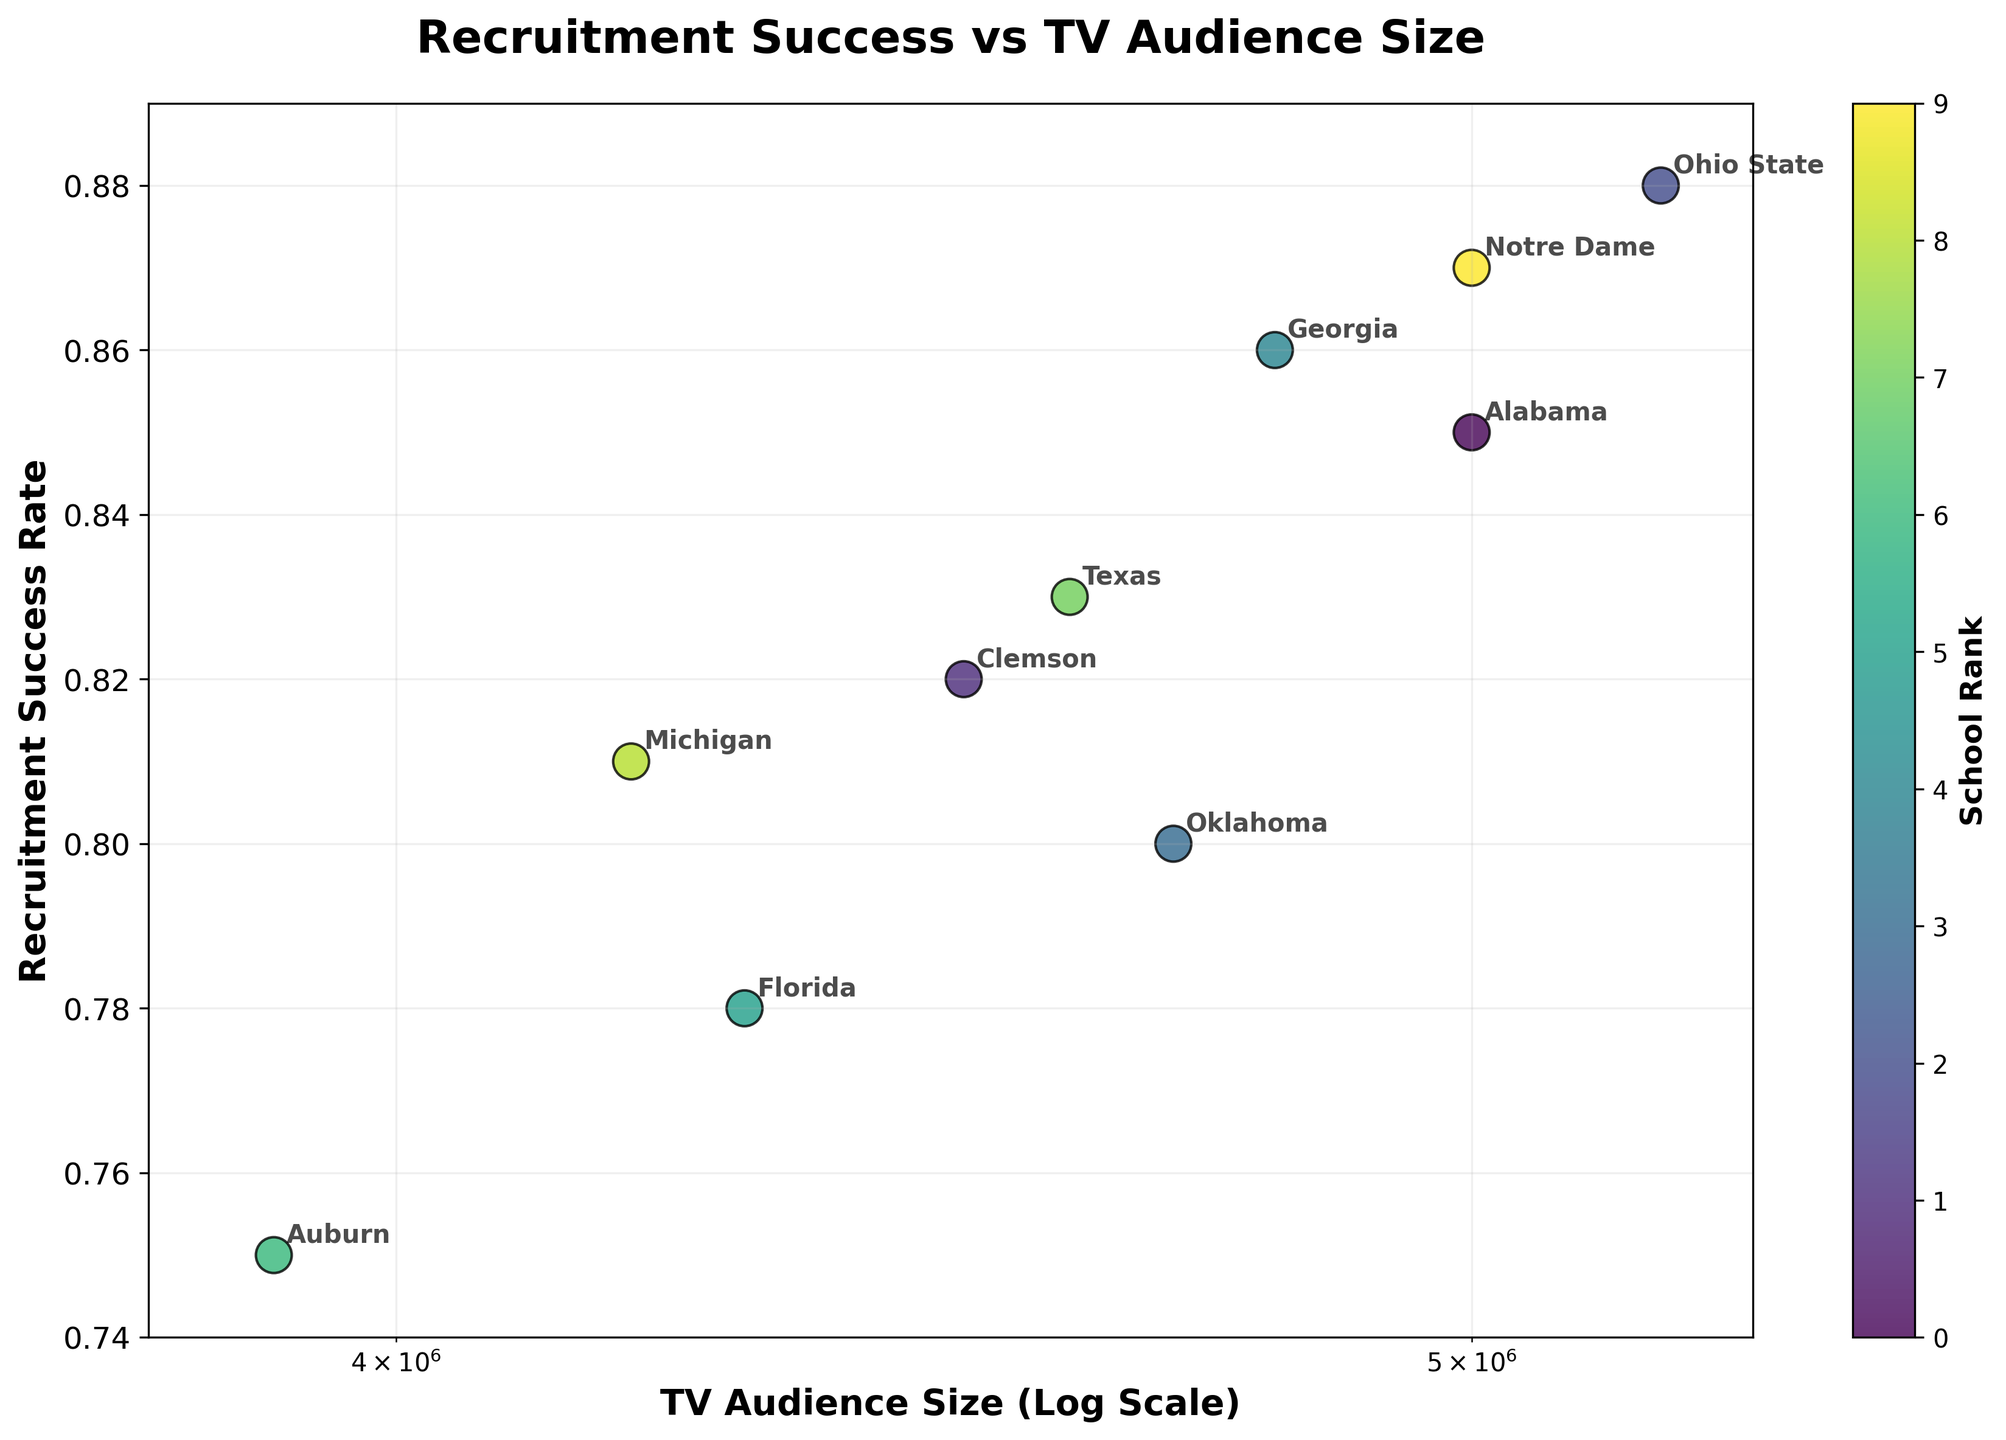What's the title of the figure? The title of the figure is located at the top and is usually displayed in a bold and larger font to summarize what the plot represents.
Answer: Recruitment Success vs TV Audience Size Which school has the highest recruitment success rate? By observing the y-axis (Recruitment Success Rate) and finding the highest point on the plot, and then looking at the label of the corresponding data point, you can identify which school has the highest recruitment success rate.
Answer: Ohio State What's the TV audience size for Michigan? Locate the data point labeled "Michigan" and find its position on the x-axis (TV Audience Size). This axis uses a log scale, so the values are logarithmically spaced.
Answer: 4200000 Between Auburn and Texas, which school has a higher TV audience size? Find the data points labeled "Auburn" and "Texas," then compare their positions on the x-axis. The one farther to the right has a higher TV audience size.
Answer: Texas How many schools have a recruitment success rate of 0.85 or higher? Count the number of data points with y-values (Recruitment Success Rate) equal to or greater than 0.85. Each point should have a label identifying the school.
Answer: 4 Which school has both a high recruitment success rate and a high TV audience size? Look for the data point that is high on the y-axis (Recruitment Success Rate) and far to the right on the x-axis (TV Audience Size). Confirm by checking the label.
Answer: Ohio State What’s the difference in recruitment success rate between the school with the highest rate and the school with the lowest rate? Identify the highest and lowest points on the y-axis and subtract the lowest rate from the highest rate. The highest rate is from Ohio State (0.88) and the lowest from Auburn (0.75).
Answer: 0.13 Which school appears closest to the average recruitment success rate of the displayed schools? Calculate the average recruitment success rate and identify the school closest to this value by comparing the y-values.
Answer: Texas Are there more schools with a TV audience size below 4500000 or above 4500000? Count the number of data points on either side of the 4500000 mark on the x-axis.
Answer: Below What does the color of the points represent? Refer to the color bar on the side of the plot; it is labeled and should indicate what the colors correspond to, in this case, "School Rank."
Answer: School Rank 